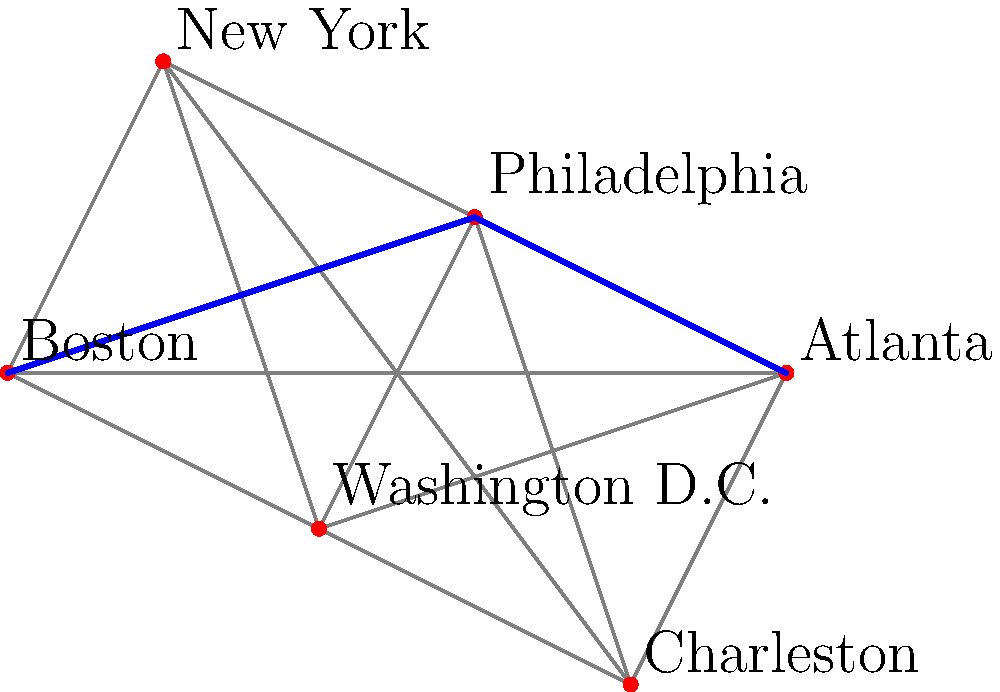As part of your upcoming sermon series on "Faith Journeys Through American History," you're planning a trip to visit key historical landmarks. The map above shows connections between six important cities in early American history, with distances represented by the length of the lines. What is the shortest path from Boston to Atlanta, and which city serves as the midpoint of this journey? To find the shortest path from Boston to Atlanta, we need to consider all possible routes and compare their lengths. Let's break this down step-by-step:

1. Observe that there are multiple paths from Boston to Atlanta.
2. The direct path would be longer than paths going through intermediate cities.
3. Looking at the map, we can see that the path through Philadelphia appears to be the shortest.
4. To verify, let's compare the Boston-Philadelphia-Atlanta path with other potential routes:
   a) Boston -> New York -> Atlanta (longer, as it goes north before south)
   b) Boston -> Washington D.C. -> Atlanta (longer, as it deviates more to the south)
   c) Boston -> Charleston -> Atlanta (much longer, as it goes far south before reaching Atlanta)
5. The Boston-Philadelphia-Atlanta path is indeed the shortest.
6. Philadelphia serves as the midpoint of this journey, as it's the intermediate city on the shortest path.

This route reflects the historical progression of the United States from its colonial roots in Boston, through the early capital in Philadelphia, to the growing importance of southern cities like Atlanta.
Answer: Boston-Philadelphia-Atlanta, with Philadelphia as the midpoint. 